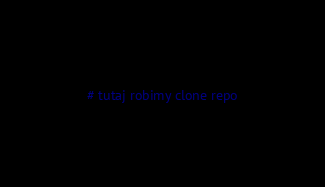<code> <loc_0><loc_0><loc_500><loc_500><_Python_># tutaj robimy clone repo</code> 